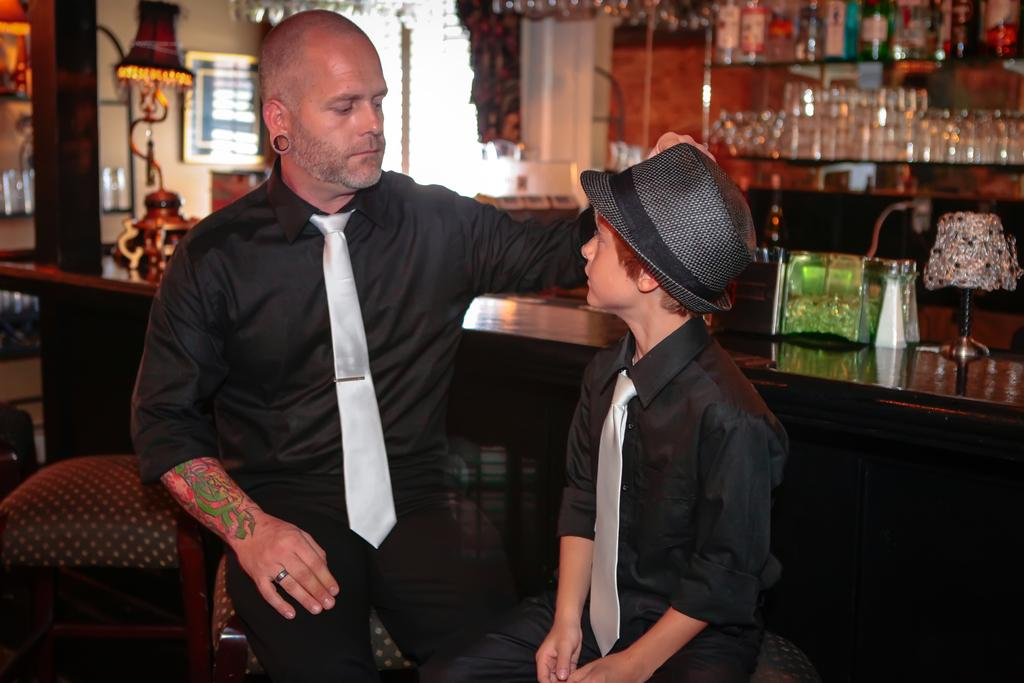How many people are present in the image? There are two people, a man and a boy, present in the image. What can be seen in the background of the image? Sunglasses are visible in the background of the image. What activity is the man and boy participating in while in jail in the image? There is no indication of a jail or any activity in the image; it only features a man and a boy. 